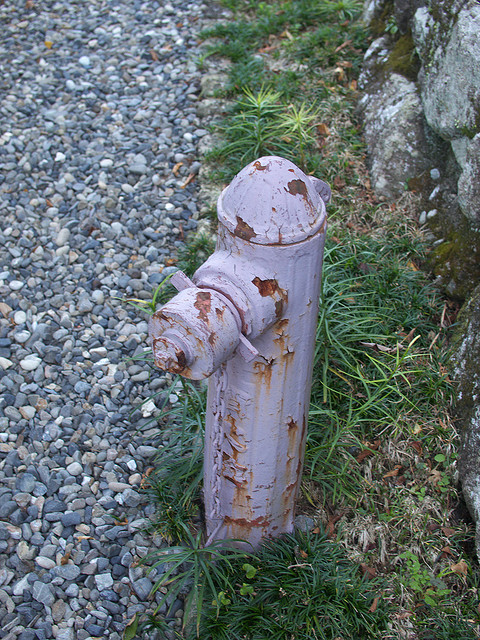<image>How old is this pump? It's unanswerable to determine the exact age of the pump. How old is this pump? I don't know how old this pump is. It can be old, very old, 20 years old, 50 years old or even older. 